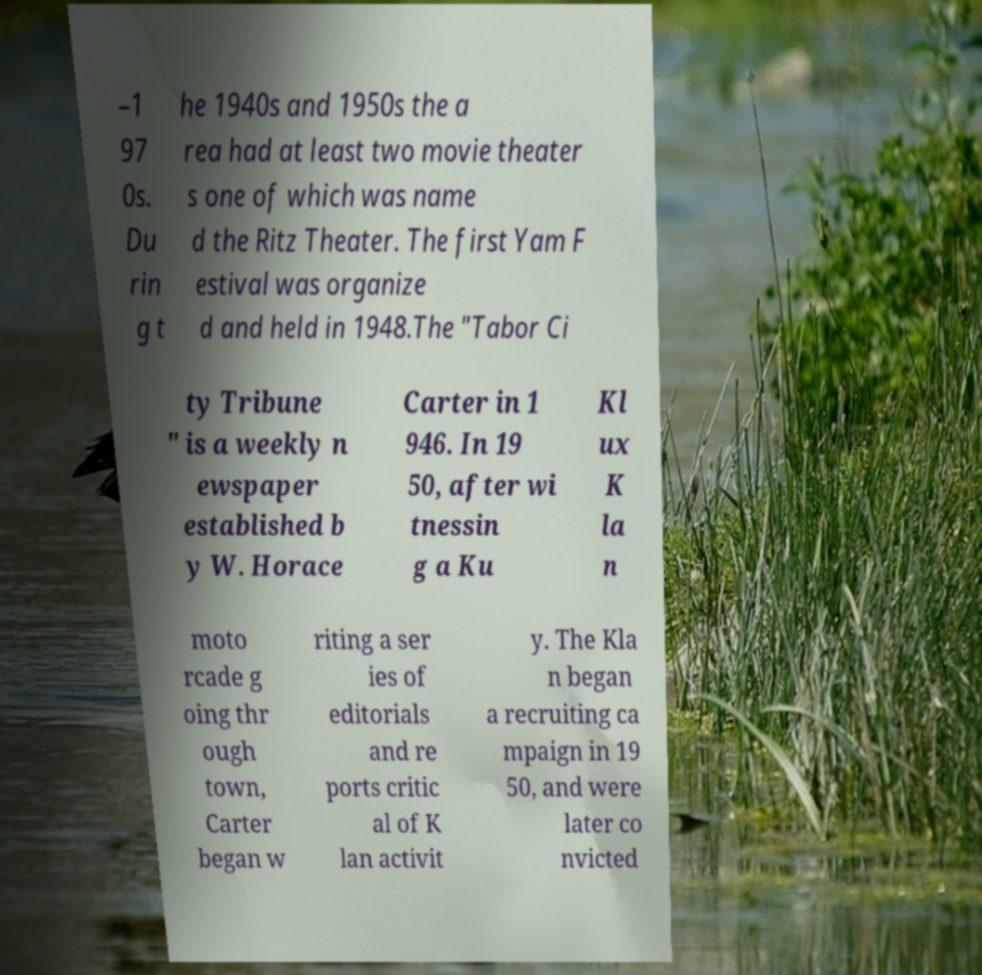I need the written content from this picture converted into text. Can you do that? –1 97 0s. Du rin g t he 1940s and 1950s the a rea had at least two movie theater s one of which was name d the Ritz Theater. The first Yam F estival was organize d and held in 1948.The "Tabor Ci ty Tribune " is a weekly n ewspaper established b y W. Horace Carter in 1 946. In 19 50, after wi tnessin g a Ku Kl ux K la n moto rcade g oing thr ough town, Carter began w riting a ser ies of editorials and re ports critic al of K lan activit y. The Kla n began a recruiting ca mpaign in 19 50, and were later co nvicted 